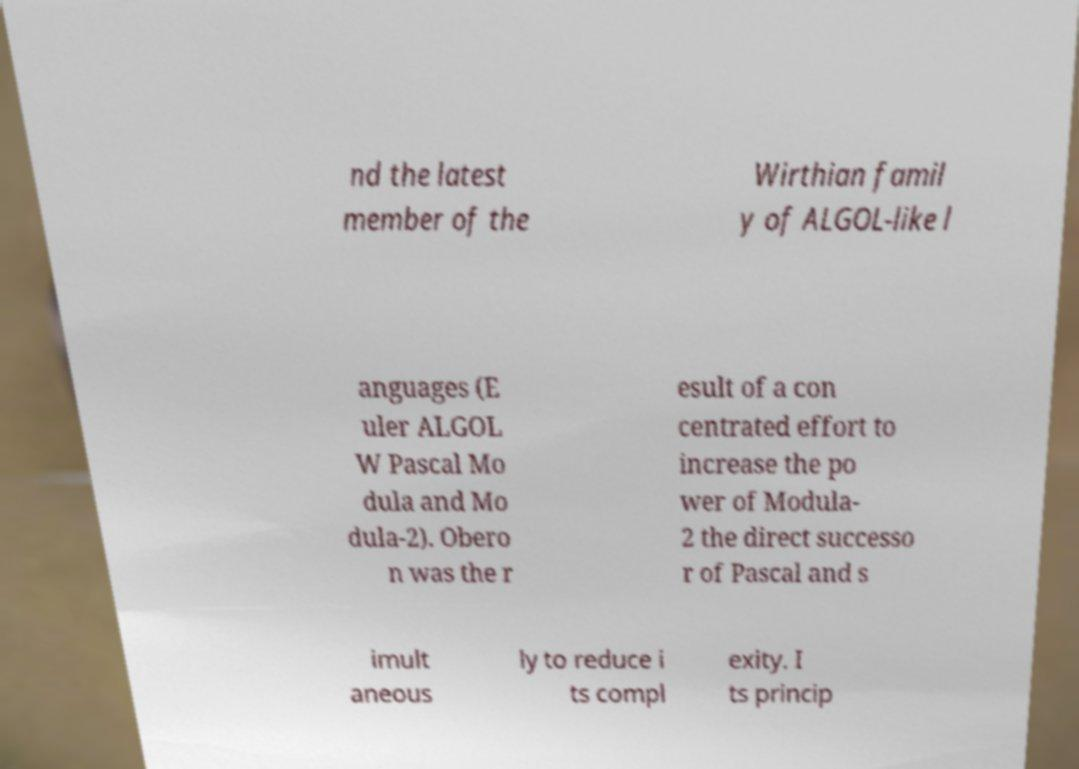Please identify and transcribe the text found in this image. nd the latest member of the Wirthian famil y of ALGOL-like l anguages (E uler ALGOL W Pascal Mo dula and Mo dula-2). Obero n was the r esult of a con centrated effort to increase the po wer of Modula- 2 the direct successo r of Pascal and s imult aneous ly to reduce i ts compl exity. I ts princip 